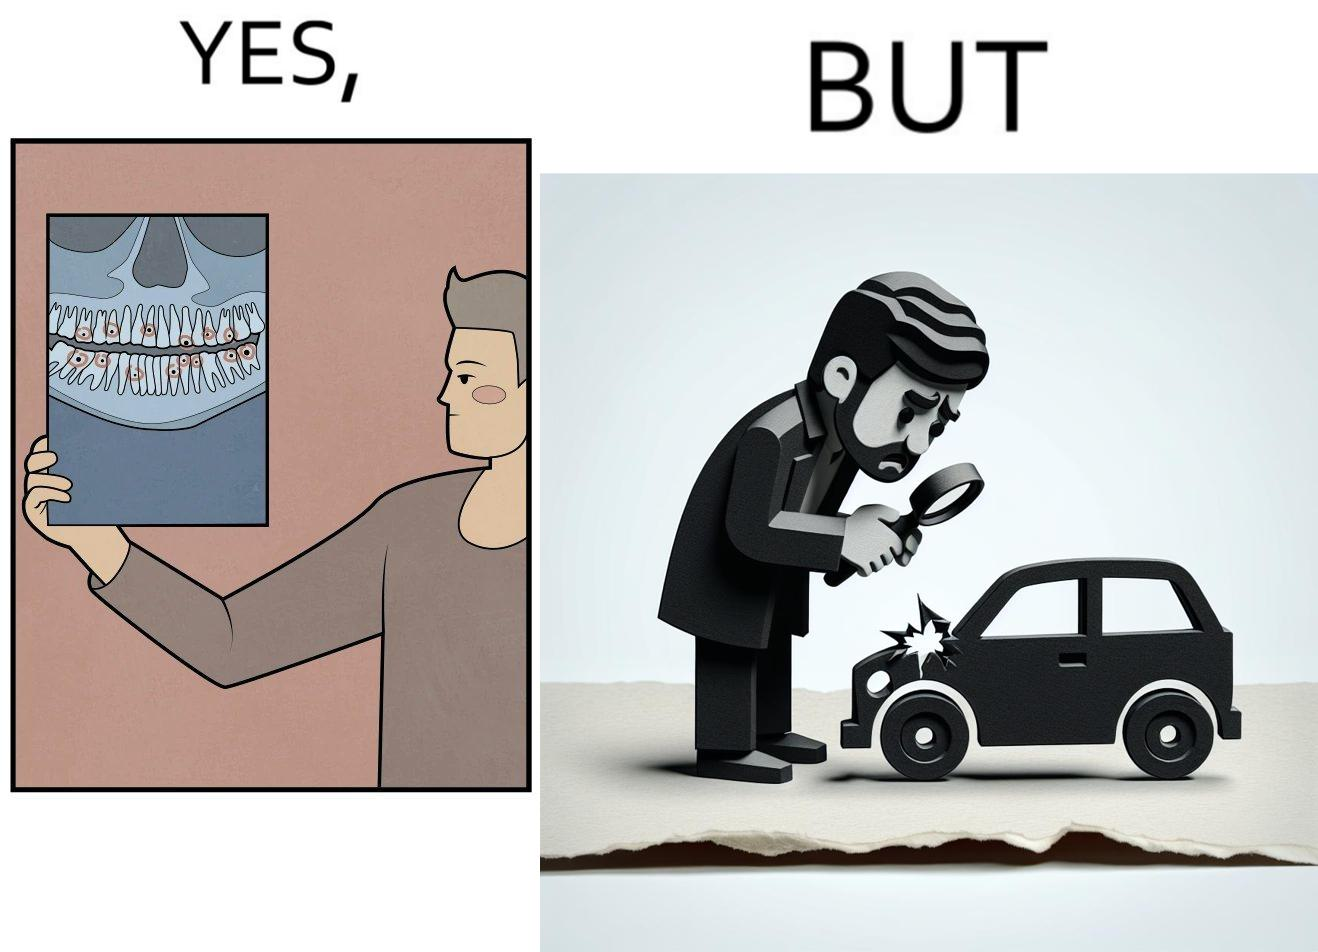Describe what you see in this image. The images are funny since they show how people are more worried about small damages to  things they can replace like cars but are not worried about permanent damages to their own health 